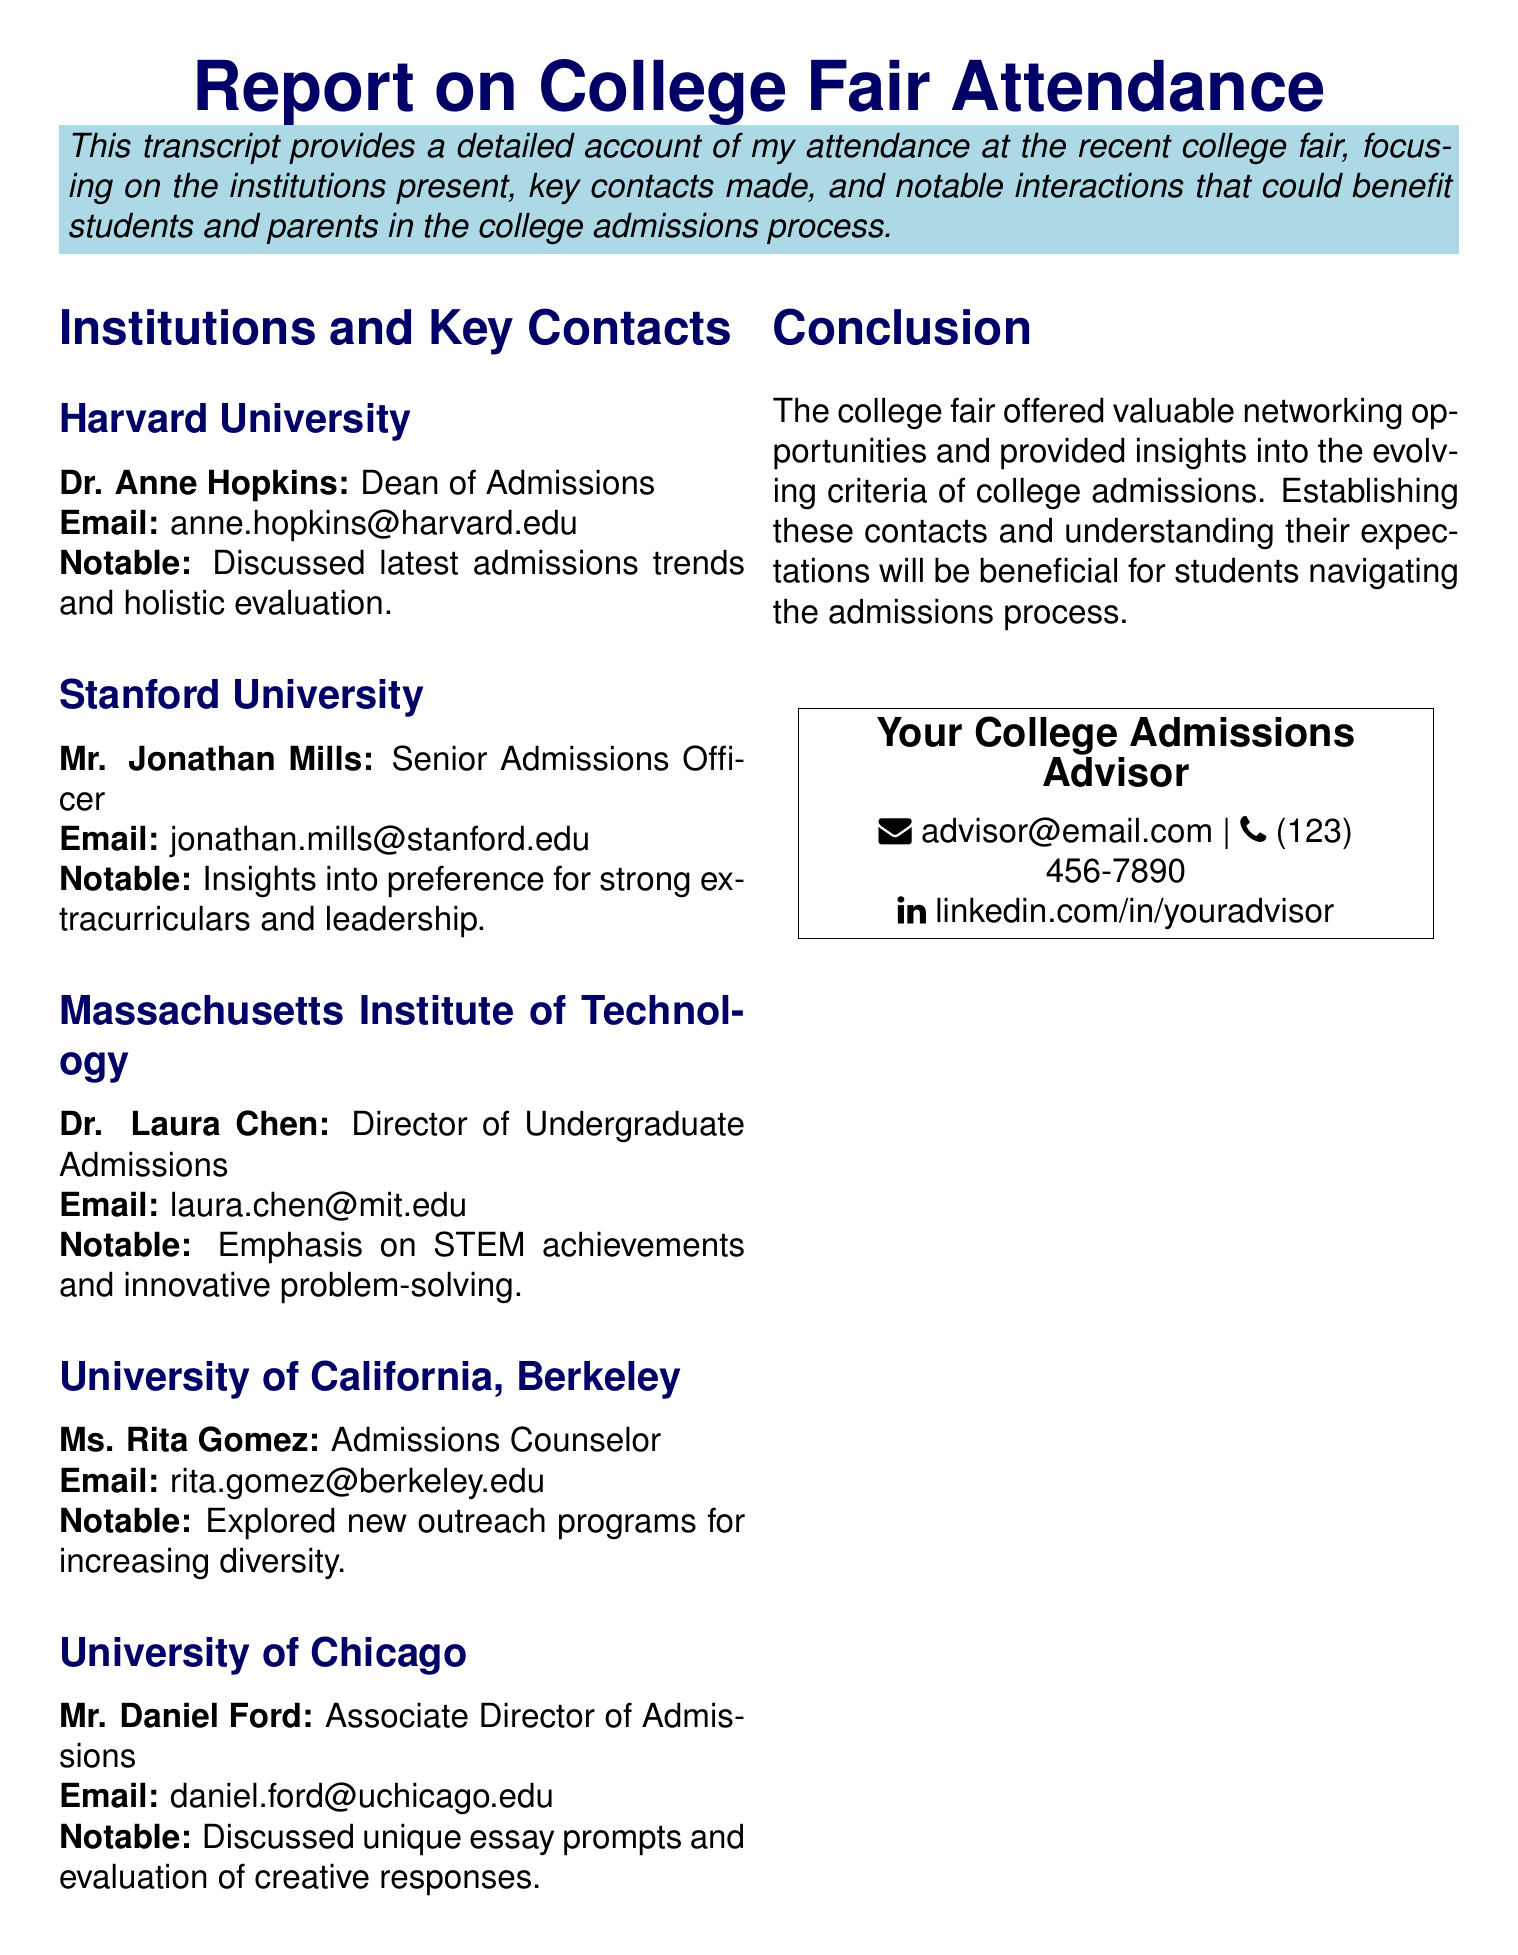What is the title of the report? The title of the report provides an overview of its content and purpose.
Answer: Report on College Fair Attendance Who is the Dean of Admissions at Harvard University? This information reveals the key contact person for Harvard University's admissions.
Answer: Dr. Anne Hopkins What notable conversation took place with University of California, Berkeley's admissions counselor? This detail highlights the institution's engagement in diversity efforts and outreach.
Answer: Explored new outreach programs for increasing diversity What is the email address of the Director of Undergraduate Admissions at MIT? The email address helps in reaching out directly for inquiries related to MIT's admissions.
Answer: laura.chen@mit.edu How many institutions are listed in the report? The count of institutions gives an overview of the report's breadth regarding college fair attendance.
Answer: Five What was emphasized by the Senior Admissions Officer of Stanford University? This insight offers a glimpse into the admissions criteria that Stanford values the most.
Answer: Strong extracurriculars and leadership What is the primary theme discussed in the conclusion of the report? Understanding the conclusion provides insight into the overall purpose of attending the college fair.
Answer: Networking opportunities and evolving criteria What is the contact email provided for the college admissions advisor? This information facilitates communication for further assistance in the admissions process.
Answer: advisor@email.com Who discussed unique essay prompts at the University of Chicago? Identifying the key contact at a major institution adds value for future interactions.
Answer: Mr. Daniel Ford 